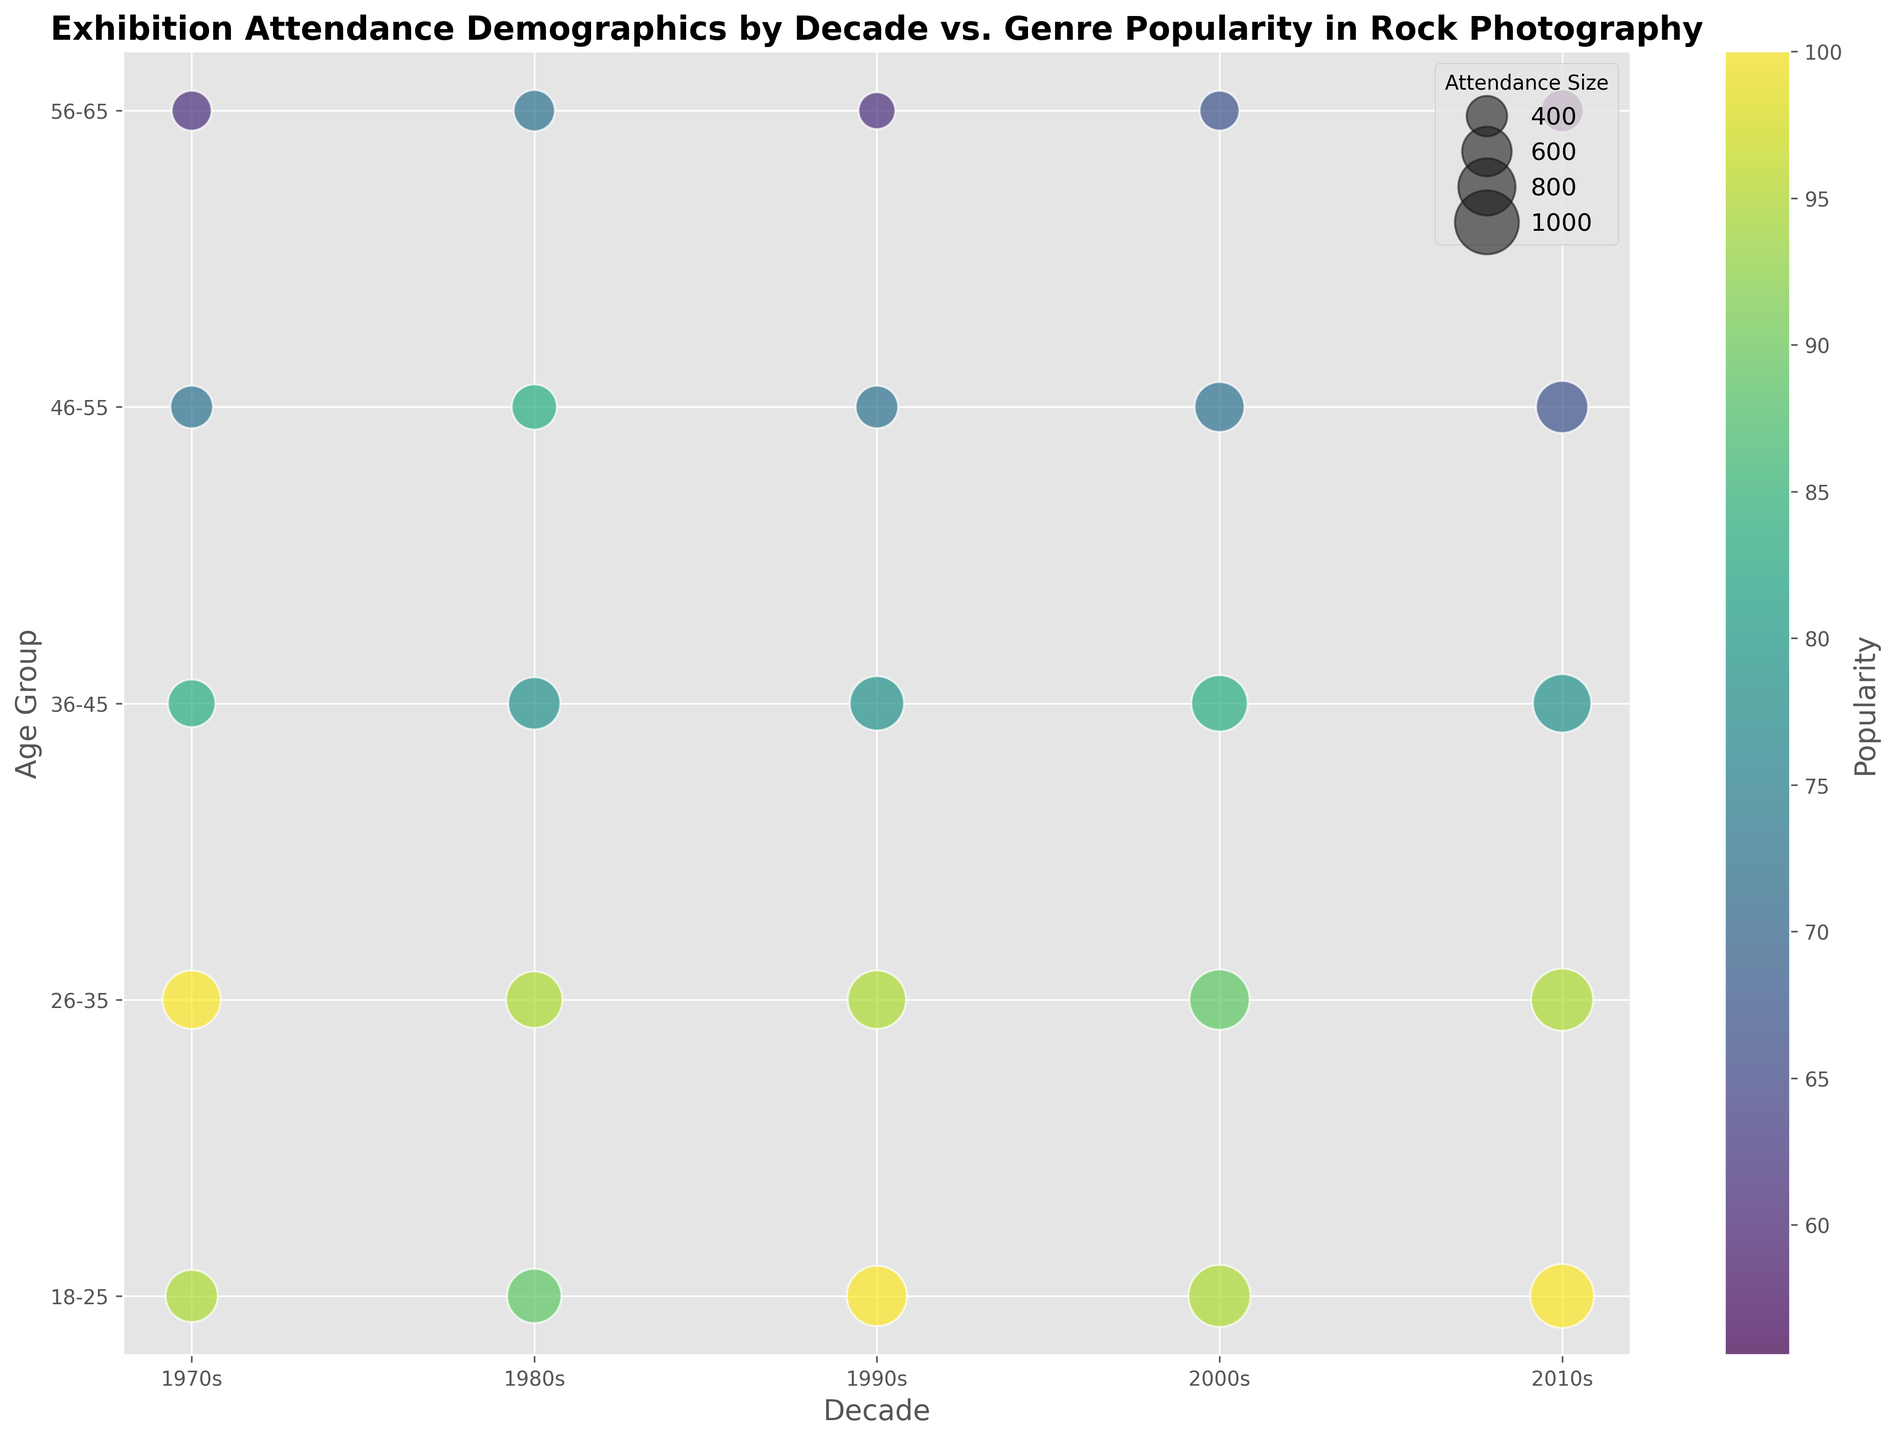What decade had the highest overall attendance for the 18-25 age group? For the 18-25 age group, look at the sizes of the bubbles across different decades. The largest bubble is in the 2010s.
Answer: 2010s Which age group had the smallest attendance in the 1980s? In the 1980s, find the smallest bubble. It belongs to the 56-65 age group.
Answer: 56-65 What is the relationship between popularity and attendance for Psychedelic Rock in the 1970s? Check the bubble color (indicating popularity) and size (indicating attendance) for Psychedelic Rock in the 1970s. Higher popularity corresponds to larger attendance.
Answer: Positive correlation Compare the attendance of Indie Rock in the 2000s and 2010s. Which is higher? Compare the bubble sizes for Indie Rock in 2000s and 2010s. The bubble in 2010s is larger.
Answer: 2010s What color represents the popularity of 75 for Hard Rock in the 1970s? Note the color on the color bar corresponding to the value 75 and find the bubble for Hard Rock in 1970s. It matches a greenish color.
Answer: Greenish What trend is observed in the age group's attendance size as we move from 18-25 to 56-65 in the 1990s? Observe the size of bubbles in the 1990s as you move from 18-25 to 56-65. The bubbles generally decrease in size.
Answer: Decreasing trend Which genre had a consistent popularity of 85 across two different decades? Find bubbles with the color indicating popularity of 85 in multiple decades. Indie Rock in the 2000s and Alternative Rock in the 2010s have this popularity.
Answer: Indie Rock and Alternative Rock What's the combined attendance for Grunge genre across all the decades? Add the attendance values for Grunge: 1600 (1990s) + 600 (1990s) = 2200.
Answer: 2200 How does the popularity of Alternative Rock change from the 1980s to the 2010s? Compare the bubble colors for Alternative Rock in the 1980s and 2010s. The color shifts from a greenish hue to a more yellowish hue.
Answer: Increases Which decade has the most varied age group attendance? Observe the range of bubble sizes for age groups in each decade. The 2000s show a wide range in bubble sizes.
Answer: 2000s 